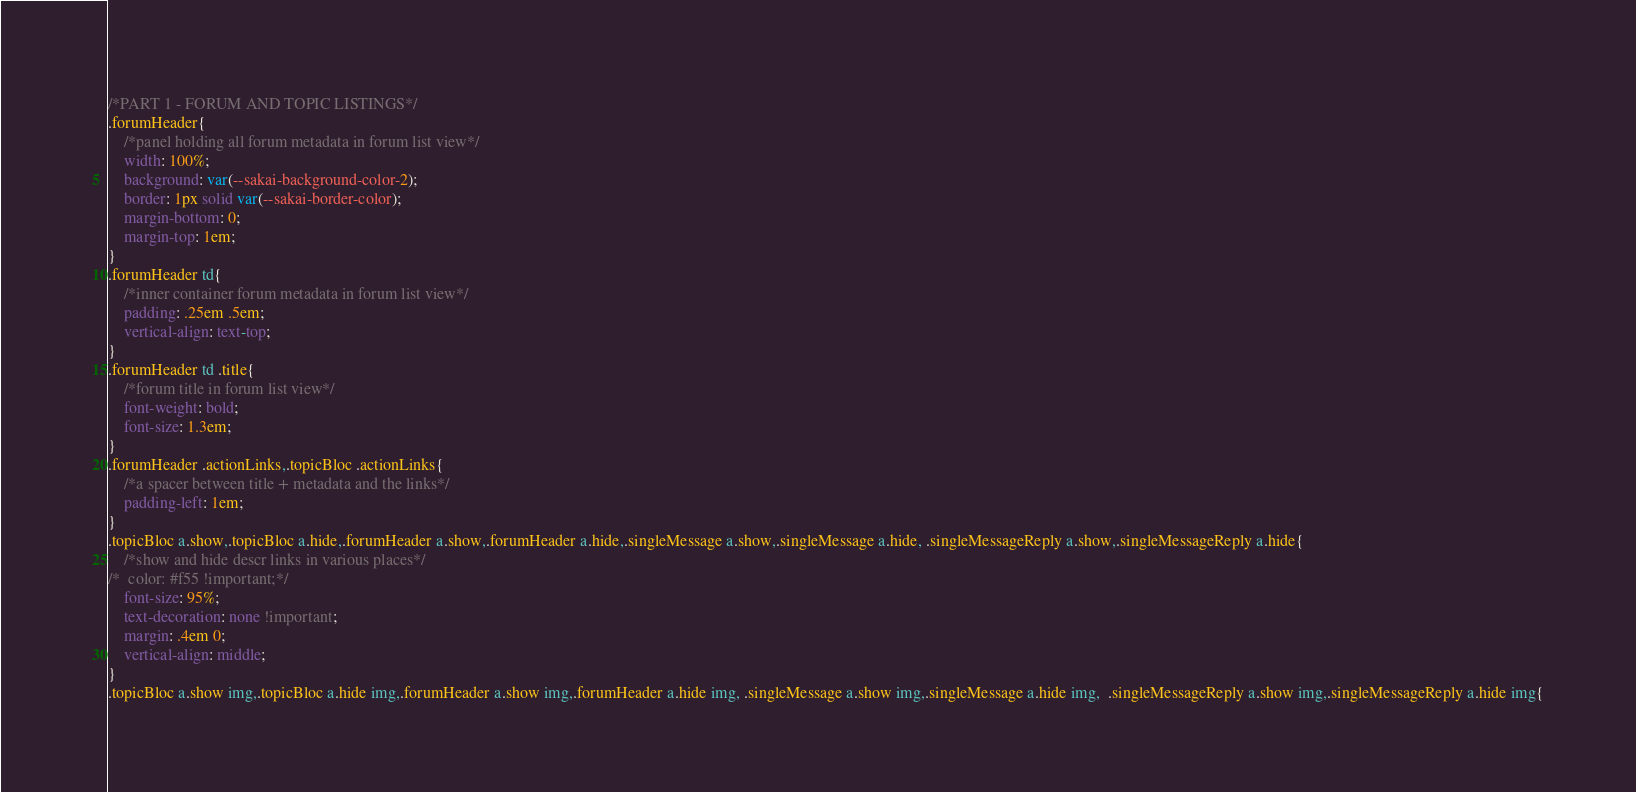Convert code to text. <code><loc_0><loc_0><loc_500><loc_500><_CSS_>/*PART 1 - FORUM AND TOPIC LISTINGS*/
.forumHeader{
	/*panel holding all forum metadata in forum list view*/
	width: 100%;
    background: var(--sakai-background-color-2);
    border: 1px solid var(--sakai-border-color);
    margin-bottom: 0;
    margin-top: 1em;
}
.forumHeader td{
	/*inner container forum metadata in forum list view*/
	padding: .25em .5em;
	vertical-align: text-top;
}
.forumHeader td .title{
	/*forum title in forum list view*/
	font-weight: bold;
	font-size: 1.3em;
}
.forumHeader .actionLinks,.topicBloc .actionLinks{
	/*a spacer between title + metadata and the links*/
	padding-left: 1em;
}
.topicBloc a.show,.topicBloc a.hide,.forumHeader a.show,.forumHeader a.hide,.singleMessage a.show,.singleMessage a.hide, .singleMessageReply a.show,.singleMessageReply a.hide{
	/*show and hide descr links in various places*/
/*	color: #f55 !important;*/
	font-size: 95%;
	text-decoration: none !important;
	margin: .4em 0;
	vertical-align: middle;
}
.topicBloc a.show img,.topicBloc a.hide img,.forumHeader a.show img,.forumHeader a.hide img, .singleMessage a.show img,.singleMessage a.hide img,  .singleMessageReply a.show img,.singleMessageReply a.hide img{</code> 